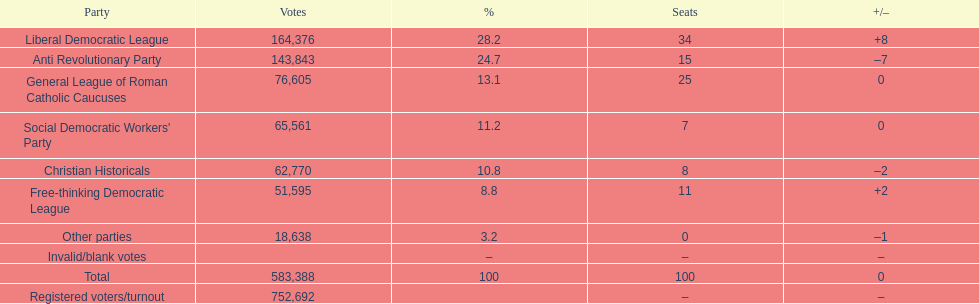Name the top three parties? Liberal Democratic League, Anti Revolutionary Party, General League of Roman Catholic Caucuses. 